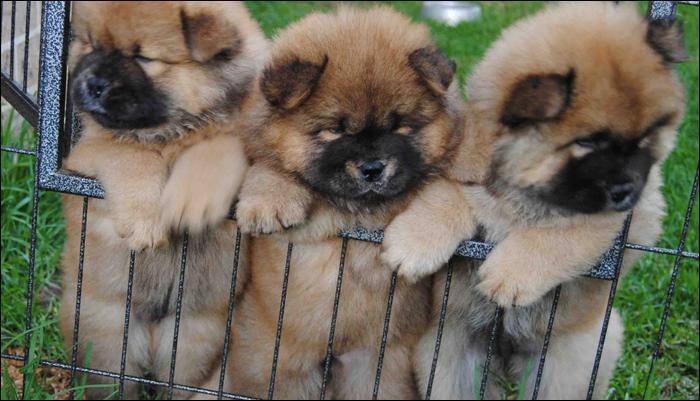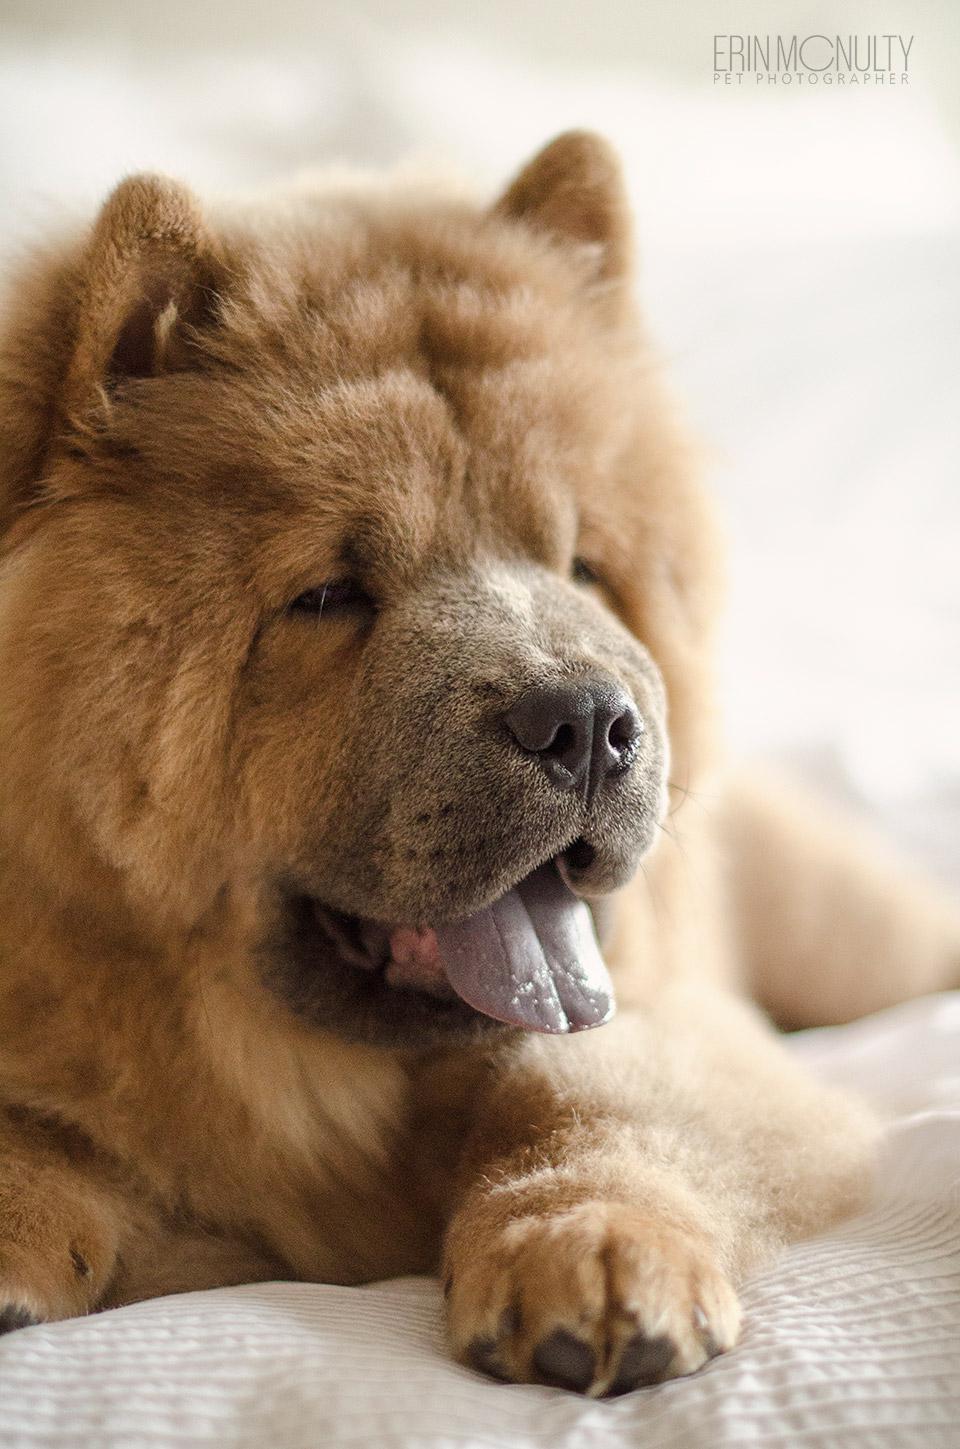The first image is the image on the left, the second image is the image on the right. Considering the images on both sides, is "In one of the image the dog is laying on a bed." valid? Answer yes or no. Yes. The first image is the image on the left, the second image is the image on the right. Given the left and right images, does the statement "All Chow dogs are on the grass." hold true? Answer yes or no. No. 